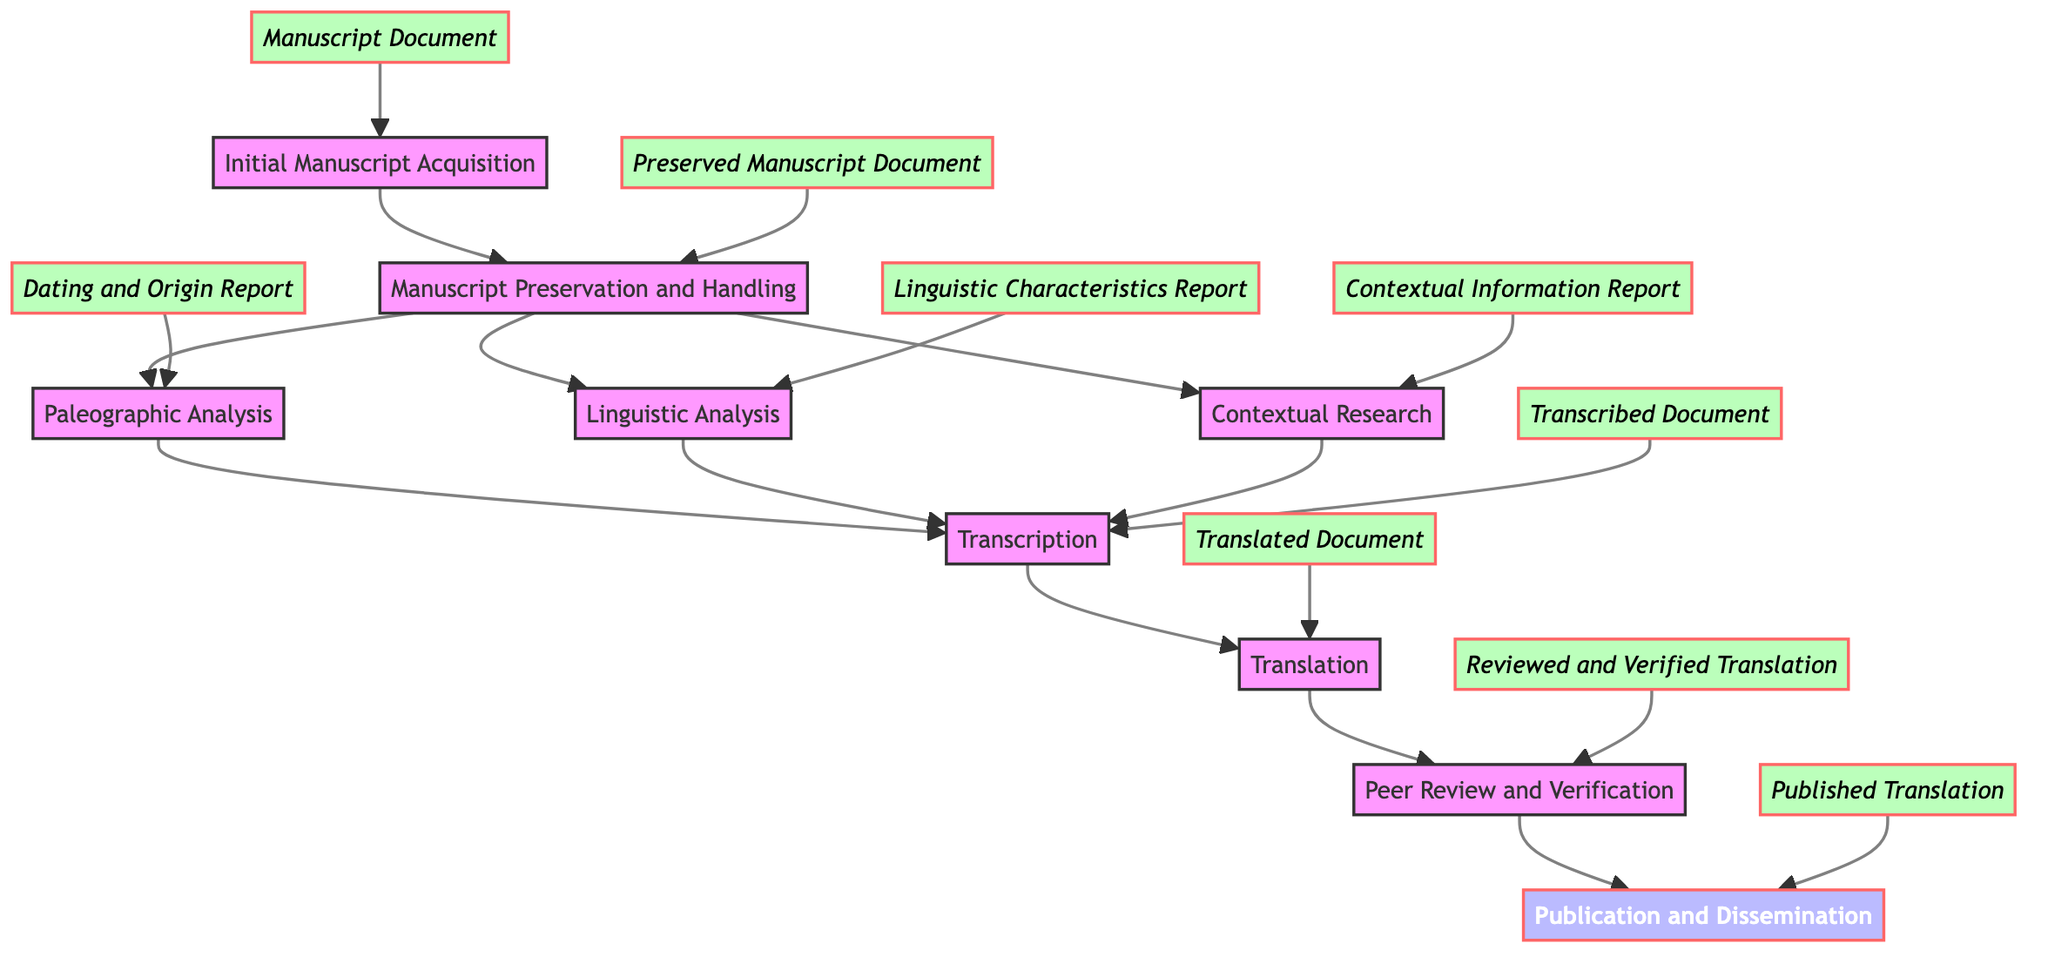What is the first step in the translation process? The diagram indicates that the first step is "Initial Manuscript Acquisition," which involves obtaining the ancient manuscript from various sources.
Answer: Initial Manuscript Acquisition How many outputs are listed in the diagram? To find the number of outputs, we can count the distinct outputs labeled at the end of each process step. There are eight outputs: Manuscript Document, Preserved Manuscript Document, Dating and Origin Report, Linguistic Characteristics Report, Contextual Information Report, Transcribed Document, Translated Document, Reviewed and Verified Translation, and Published Translation.
Answer: Eight What document comes after the Paleographic Analysis? The flow of the diagram shows that after "Paleographic Analysis," the next step is "Transcription."
Answer: Transcription Which processes branch out from Manuscript Preservation and Handling? The diagram illustrates that three processes branch out from "Manuscript Preservation and Handling": "Paleographic Analysis," "Linguistic Analysis," and "Contextual Research."
Answer: Paleographic Analysis, Linguistic Analysis, Contextual Research What is the final output in the translational flow? The last step in the diagram indicates that "Publication and Dissemination" is the final output, which is produced after the peer review stage.
Answer: Published Translation What is required before the Translation step? According to the diagram, "Transcription" must be completed before proceeding to the "Translation" step.
Answer: Transcription How does the Translated Document reach the final output? The flow shows that after the "Translated Document," it goes through the "Peer Review and Verification," which confirms its accuracy, followed by the "Publication and Dissemination" that finalizes the process.
Answer: Peer Review and Verification, Publication and Dissemination What do the outputs represent in the diagram? Each output in the diagram represents the result of completing a specific process, summarizing what is produced at each stage from acquiring the manuscript to publishing the translation.
Answer: Results of processes 